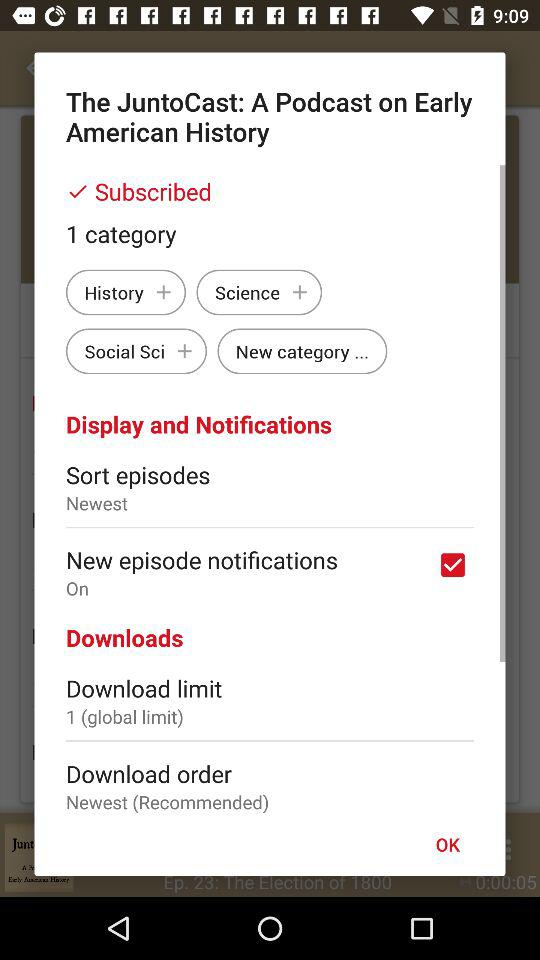How many categories are there?
Answer the question using a single word or phrase. 1 